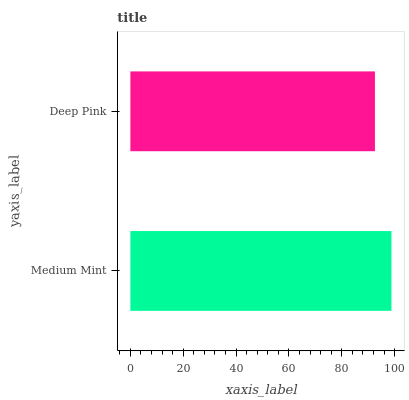Is Deep Pink the minimum?
Answer yes or no. Yes. Is Medium Mint the maximum?
Answer yes or no. Yes. Is Deep Pink the maximum?
Answer yes or no. No. Is Medium Mint greater than Deep Pink?
Answer yes or no. Yes. Is Deep Pink less than Medium Mint?
Answer yes or no. Yes. Is Deep Pink greater than Medium Mint?
Answer yes or no. No. Is Medium Mint less than Deep Pink?
Answer yes or no. No. Is Medium Mint the high median?
Answer yes or no. Yes. Is Deep Pink the low median?
Answer yes or no. Yes. Is Deep Pink the high median?
Answer yes or no. No. Is Medium Mint the low median?
Answer yes or no. No. 